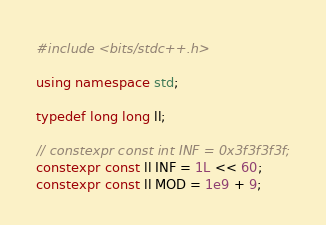<code> <loc_0><loc_0><loc_500><loc_500><_C++_>#include <bits/stdc++.h>

using namespace std;

typedef long long ll;

// constexpr const int INF = 0x3f3f3f3f;
constexpr const ll INF = 1L << 60;
constexpr const ll MOD = 1e9 + 9;
</code> 